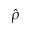<formula> <loc_0><loc_0><loc_500><loc_500>\hat { \rho }</formula> 